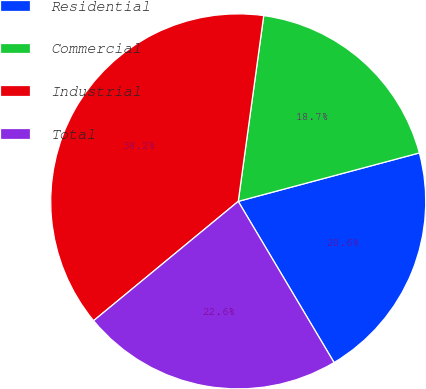Convert chart. <chart><loc_0><loc_0><loc_500><loc_500><pie_chart><fcel>Residential<fcel>Commercial<fcel>Industrial<fcel>Total<nl><fcel>20.62%<fcel>18.67%<fcel>38.15%<fcel>22.56%<nl></chart> 